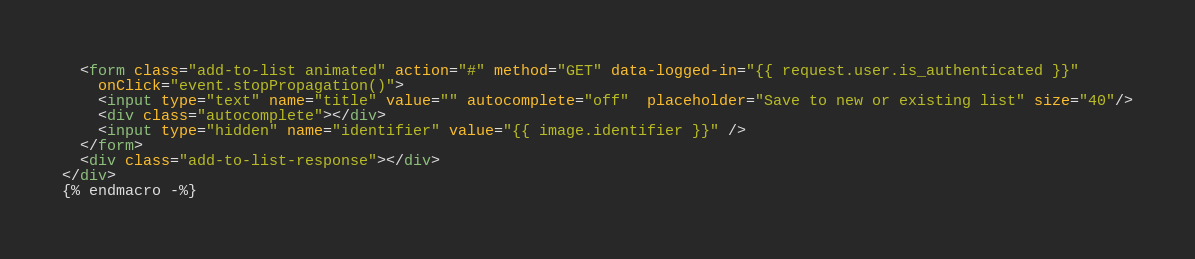<code> <loc_0><loc_0><loc_500><loc_500><_HTML_>  <form class="add-to-list animated" action="#" method="GET" data-logged-in="{{ request.user.is_authenticated }}"
    onClick="event.stopPropagation()">
    <input type="text" name="title" value="" autocomplete="off"  placeholder="Save to new or existing list" size="40"/>
    <div class="autocomplete"></div>
    <input type="hidden" name="identifier" value="{{ image.identifier }}" />
  </form>
  <div class="add-to-list-response"></div>
</div>
{% endmacro -%}
</code> 